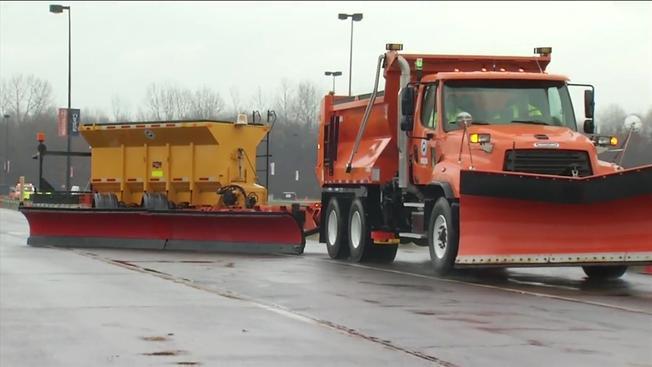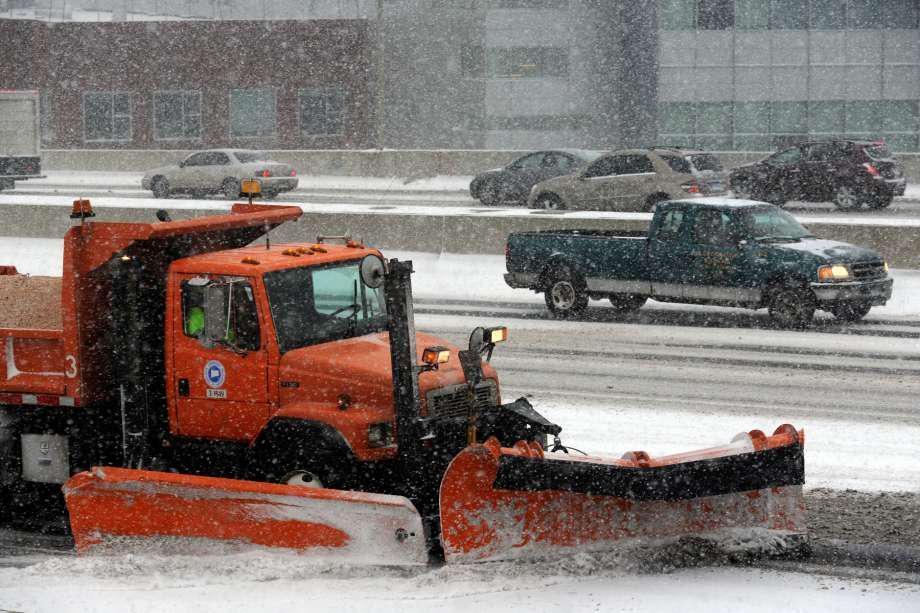The first image is the image on the left, the second image is the image on the right. Given the left and right images, does the statement "The left and right image contains the same number of snow truck with at least one with an orange plow." hold true? Answer yes or no. Yes. 